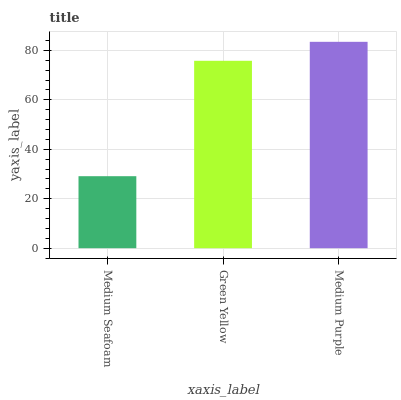Is Medium Seafoam the minimum?
Answer yes or no. Yes. Is Medium Purple the maximum?
Answer yes or no. Yes. Is Green Yellow the minimum?
Answer yes or no. No. Is Green Yellow the maximum?
Answer yes or no. No. Is Green Yellow greater than Medium Seafoam?
Answer yes or no. Yes. Is Medium Seafoam less than Green Yellow?
Answer yes or no. Yes. Is Medium Seafoam greater than Green Yellow?
Answer yes or no. No. Is Green Yellow less than Medium Seafoam?
Answer yes or no. No. Is Green Yellow the high median?
Answer yes or no. Yes. Is Green Yellow the low median?
Answer yes or no. Yes. Is Medium Seafoam the high median?
Answer yes or no. No. Is Medium Seafoam the low median?
Answer yes or no. No. 